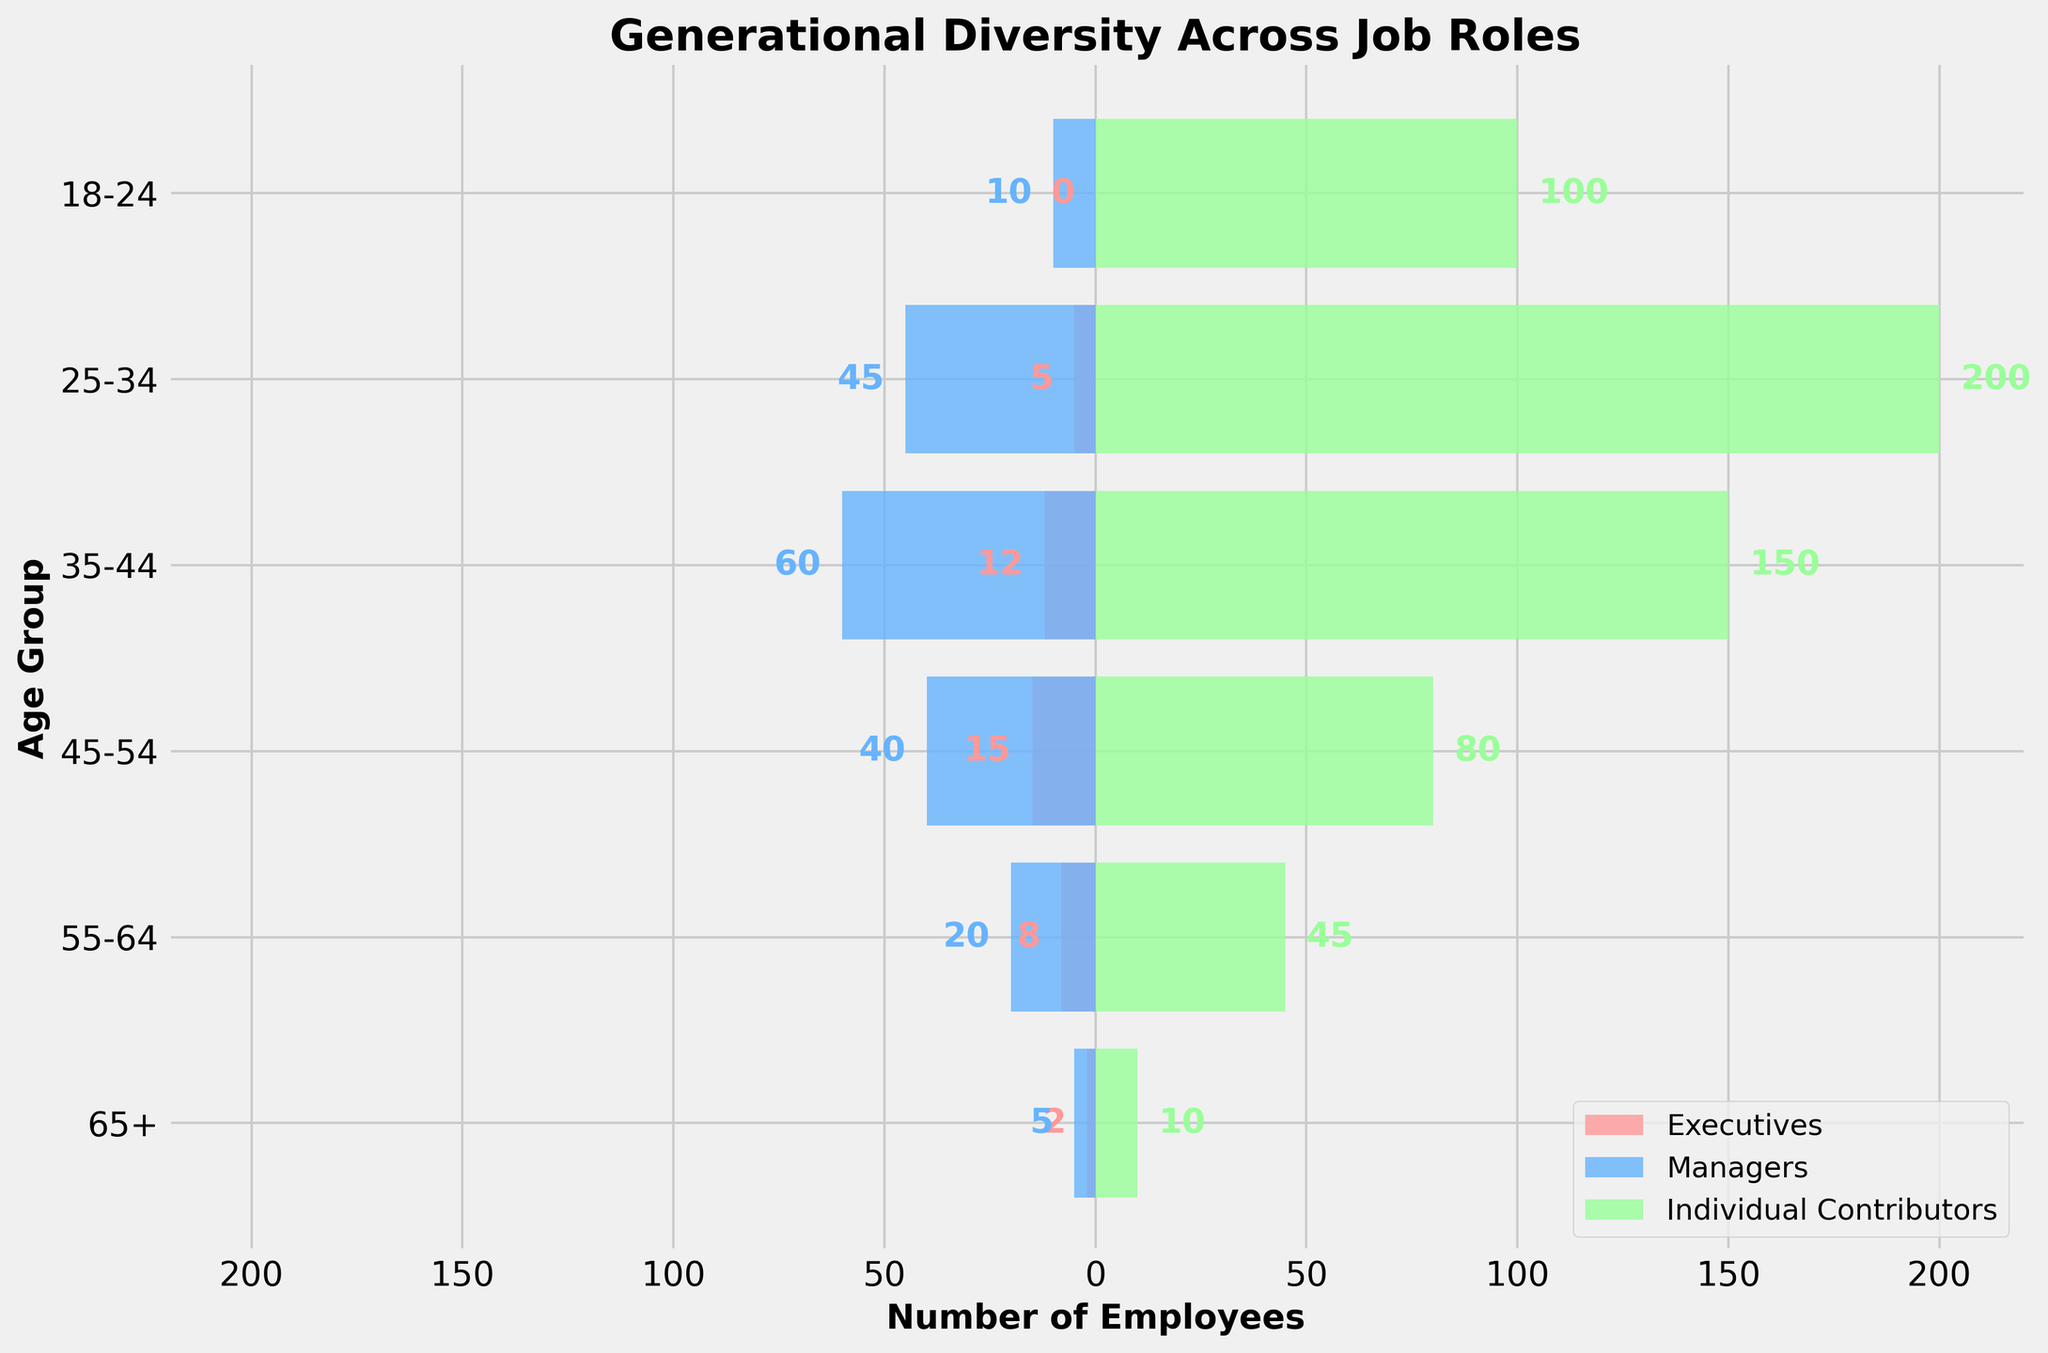What is the title of the figure? Look at the top of the figure where the title is usually placed.
Answer: Generational Diversity Across Job Roles What is the total number of Executives in the 25-34 age group? Observe the bar length for the 25-34 age group under the Executives category.
Answer: 5 How many more Managers are there in the 45-54 age group compared to the 55-64 age group? Check the bar lengths for Managers in the 45-54 and 55-64 age groups, and subtract the latter from the former (40 - 20).
Answer: 20 Which age group has the highest number of Individual Contributors? Look for the longest positive bar in the Individual Contributors category.
Answer: 25-34 What is the total number of employees in the 35-44 age group across all roles? Add the number of Executives, Managers, and Individual Contributors in the 35-44 age group (12 + 60 + 150).
Answer: 222 How many more Individual Contributors are there than Managers in the 18-24 age group? Subtract the number of Managers from Individual Contributors in the 18-24 age group (100 - 10).
Answer: 90 Which role has the fewest employees in the 65+ age group? Compare the bar lengths for Executives, Managers, and Individual Contributors in the 65+ age group to identify the shortest bar.
Answer: Executives In which age group is the number of Managers closest to the number of Individual Contributors? Evaluate the bar lengths for Managers and Individual Contributors across all age groups and find where the difference is smallest.
Answer: 18-24 What is the sum of all employees in the 55-64 age group across all roles? Add the number of Executives, Managers, and Individual Contributors in the 55-64 age group (8 + 20 + 45).
Answer: 73 How does the number of employees in the 18-24 age group compare to the 65+ age group across all roles? Calculate the total number of employees in both age groups (0 + 10 + 100 for 18-24, and 2 + 5 + 10 for 65+), and compare the sums.
Answer: 110 more in 18-24 